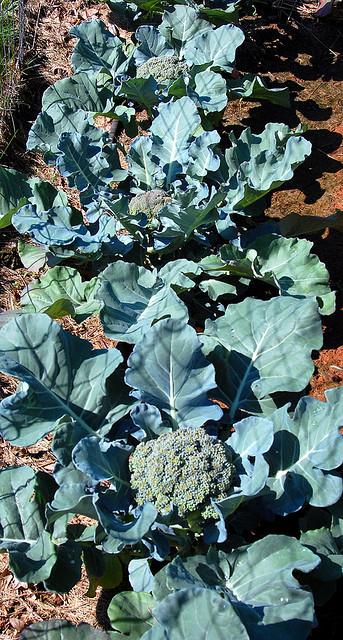What is green?
Short answer required. Broccoli. What kind of plant is this?
Write a very short answer. Broccoli. What color are the leaves?
Give a very brief answer. Green. 